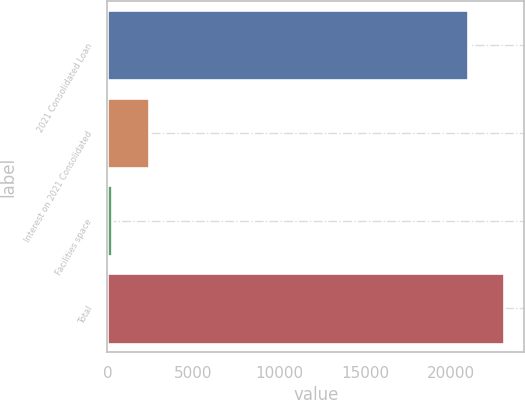Convert chart to OTSL. <chart><loc_0><loc_0><loc_500><loc_500><bar_chart><fcel>2021 Consolidated Loan<fcel>Interest on 2021 Consolidated<fcel>Facilities space<fcel>Total<nl><fcel>20960<fcel>2419.5<fcel>274<fcel>23105.5<nl></chart> 